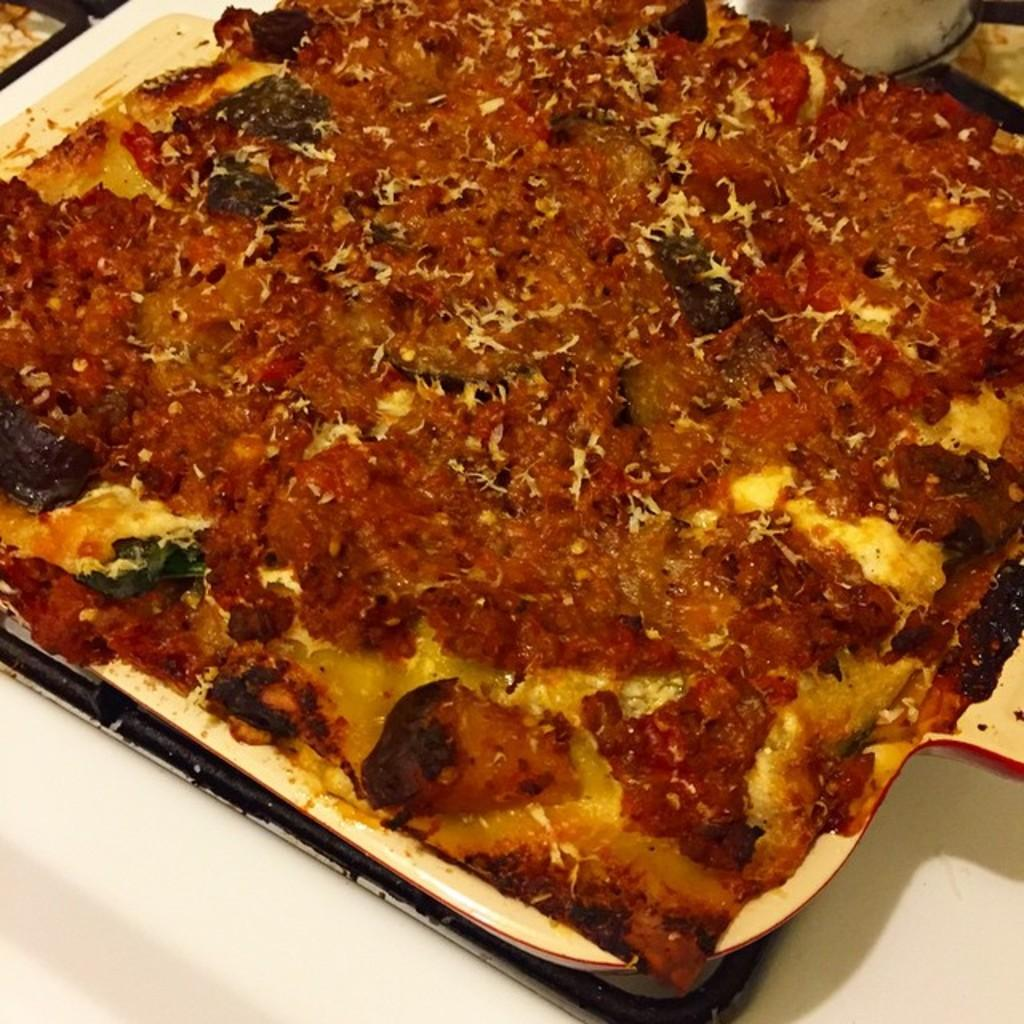What object is in the center of the image? There is a plate in the center of the image. What is on the plate? A food item is present in the plate. Can you describe the location of the plate in the image? The plate is located in the center of the image. How does the plate change its color when someone laughs in the image? There is no person laughing in the image, and the plate does not change color. 